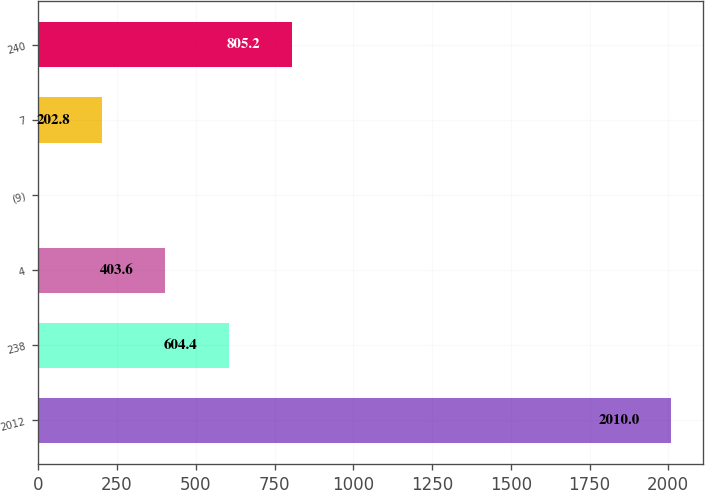Convert chart to OTSL. <chart><loc_0><loc_0><loc_500><loc_500><bar_chart><fcel>2012<fcel>238<fcel>4<fcel>(9)<fcel>7<fcel>240<nl><fcel>2010<fcel>604.4<fcel>403.6<fcel>2<fcel>202.8<fcel>805.2<nl></chart> 